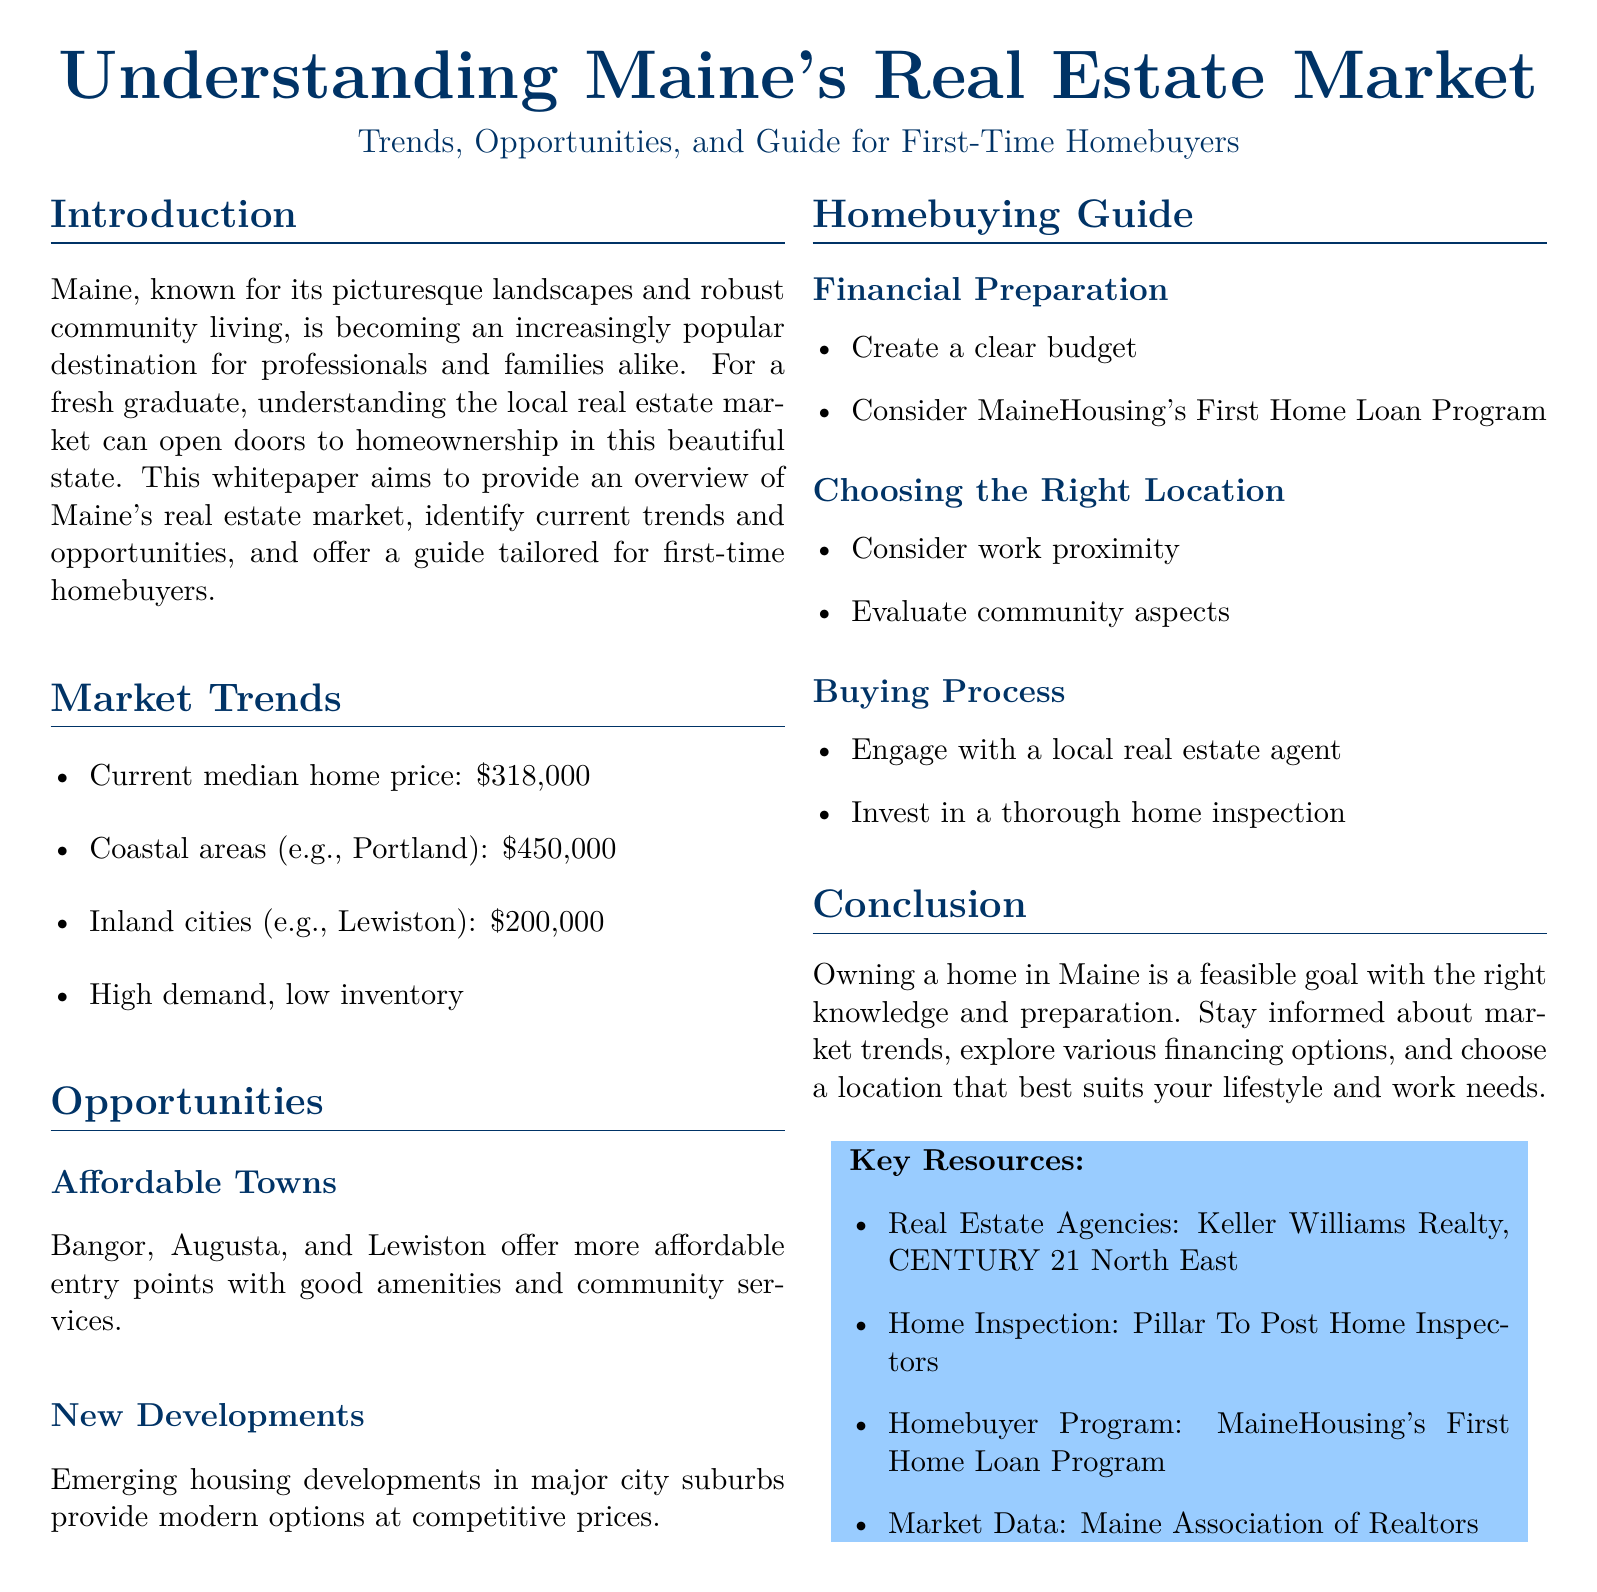what is the current median home price in Maine? The median home price in Maine is listed in the document as the current figure.
Answer: $318,000 what is the median home price in coastal areas like Portland? The document specifies the median home price in coastal areas.
Answer: $450,000 which towns are identified as affordable entry points? The document names several towns as affordable options for homebuyers.
Answer: Bangor, Augusta, and Lewiston what program can first-time homebuyers consider for financing? The document mentions a specific homebuyer program that can assist first-time buyers.
Answer: MaineHousing's First Home Loan Program what is a crucial first step in the homebuying process? The document highlights an important action to take when starting the homebuying process.
Answer: Engage with a local real estate agent why is it essential to evaluate community aspects when choosing a location? The document indicates that understanding community elements is important in the decision-making process.
Answer: To ensure it suits lifestyle and work needs what type of inspection should be invested in during the buying process? The document advises on a specific type of inspection that should be prioritized when purchasing a home.
Answer: Thorough home inspection which resource is mentioned for market data? The document lists a specific organization for obtaining real estate market data.
Answer: Maine Association of Realtors 